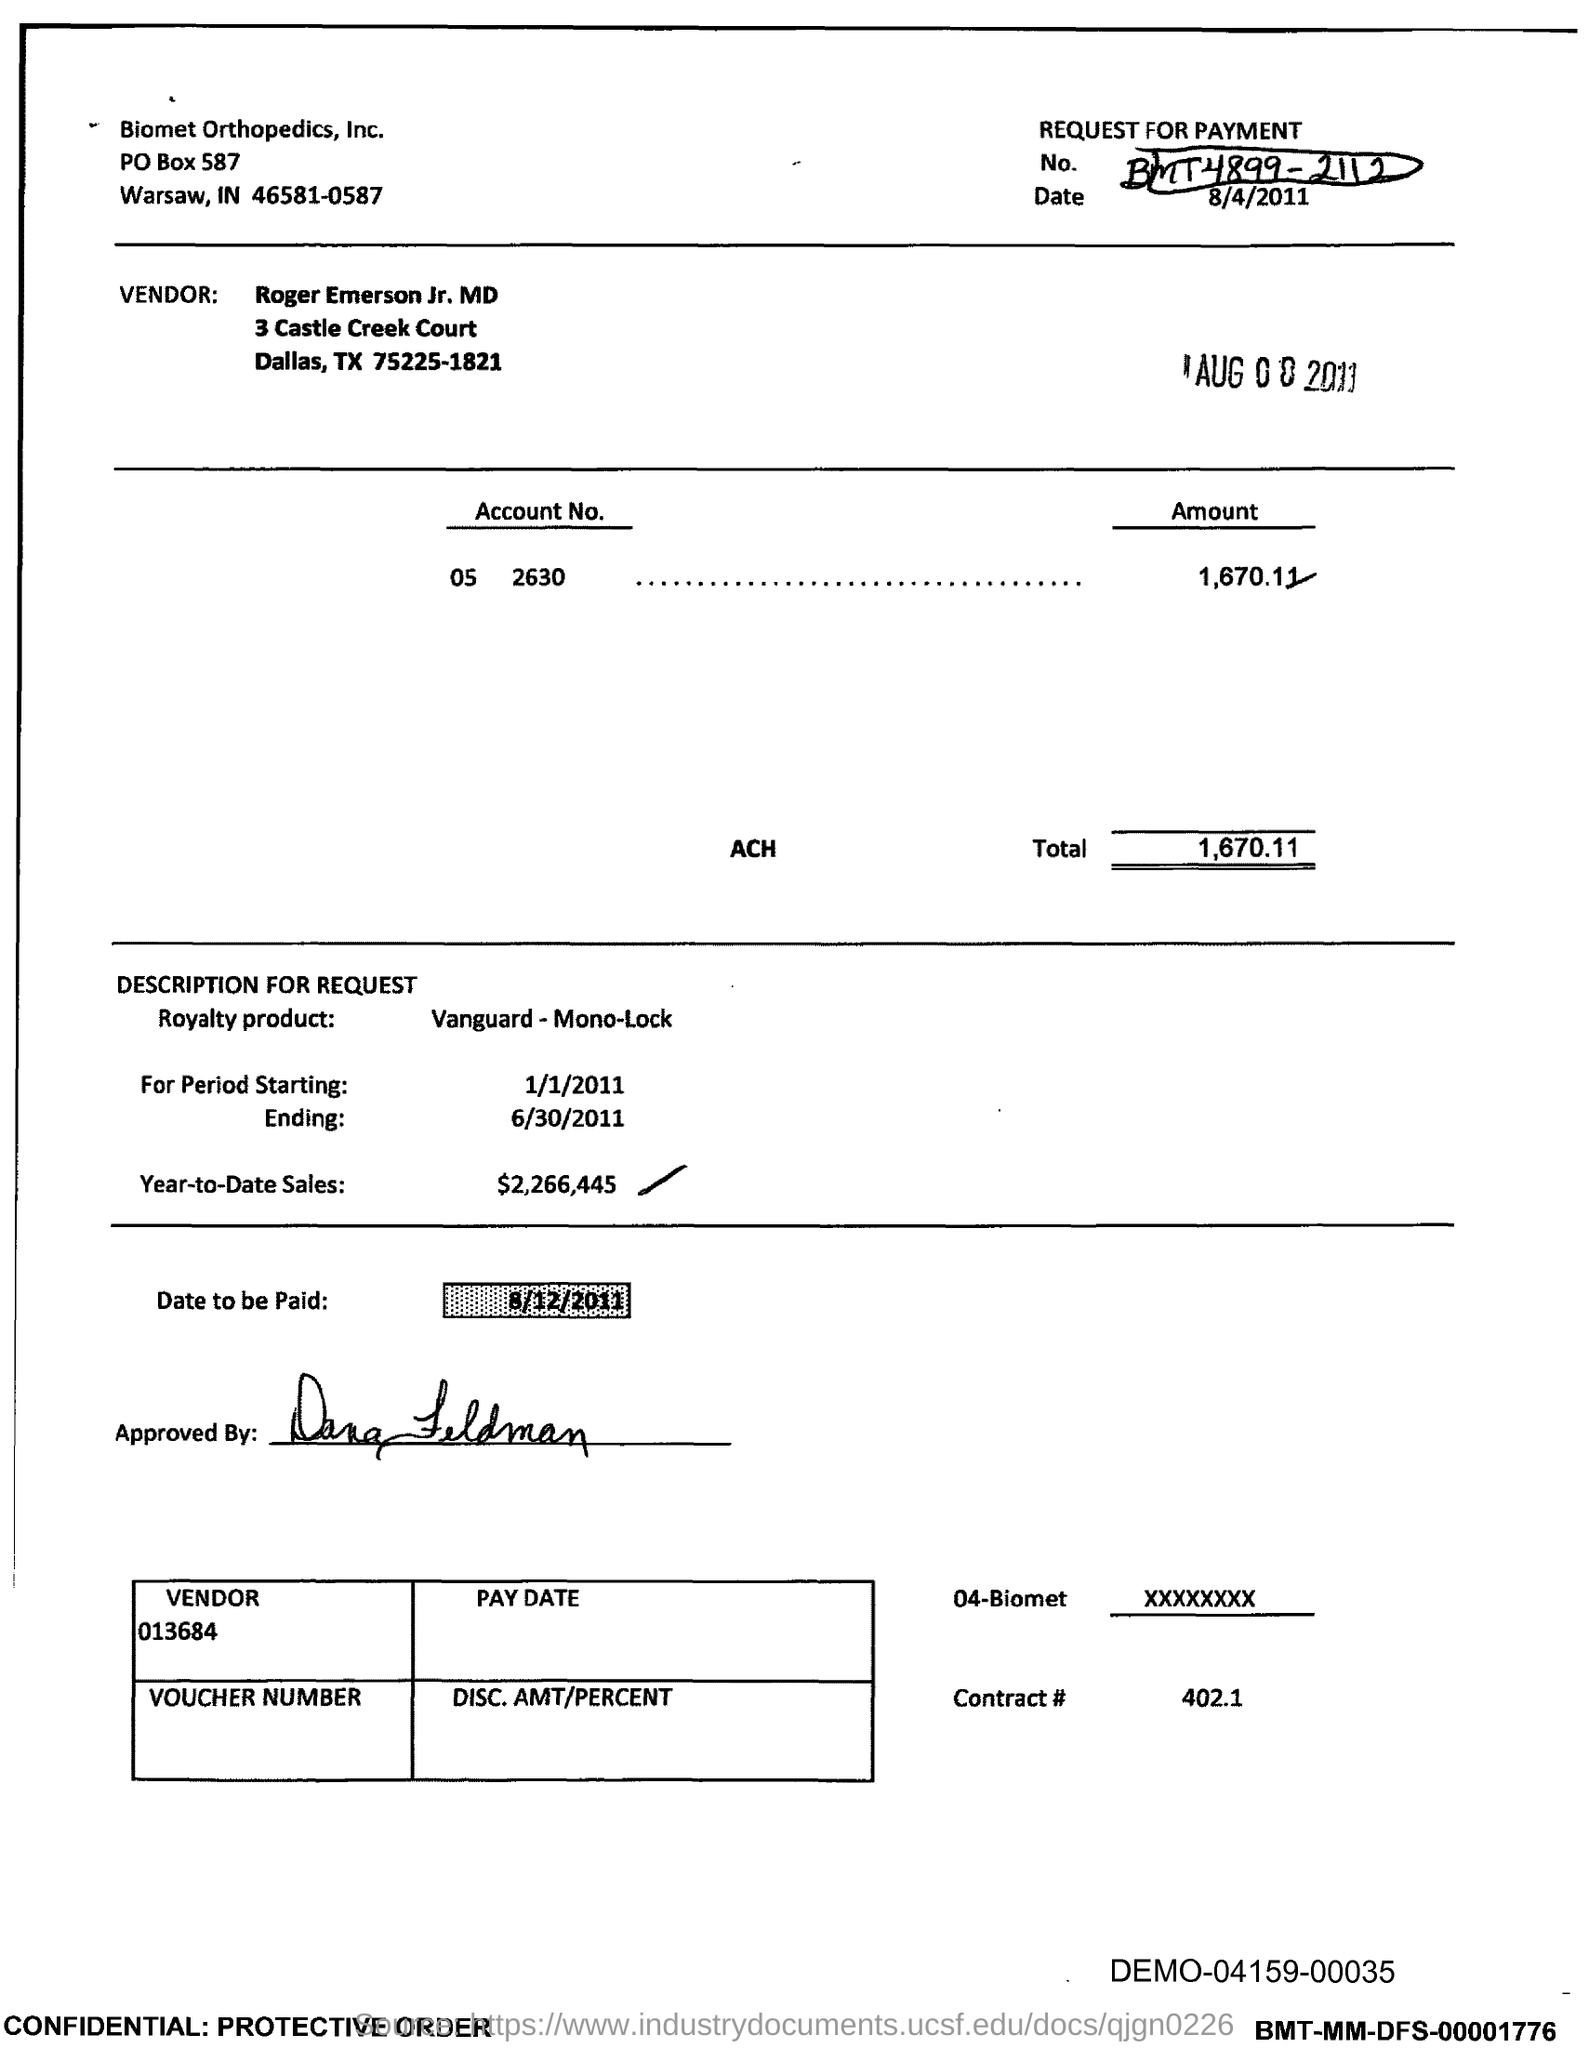What is the request for payment No.?
Offer a very short reply. BMT4899 - 2112. Who is the vendor mentioned in the document?
Keep it short and to the point. Roger Emerson Jr. MD. What is the Account No. given in the document?
Your answer should be very brief. 05 2630. What is the total amount mentioned in the document?
Make the answer very short. 1,670.11. What is the royalty product given in the document?
Ensure brevity in your answer.  Vanguard-Mono-Lock. What is the Year-to-Date Sales of the royalty product?
Provide a succinct answer. $2,266,445. What is the start date of the royalty period?
Keep it short and to the point. 1/1/2011. What is the end date of the royalty period?
Your response must be concise. 6/30/2011. What is the contract # given in the document?
Your response must be concise. 402.1. What is the vendor number given in the document?
Give a very brief answer. 013684. 